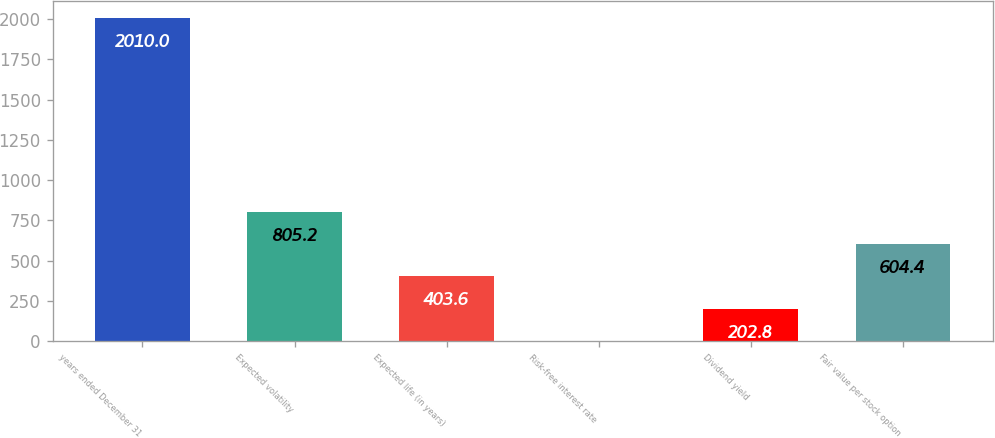<chart> <loc_0><loc_0><loc_500><loc_500><bar_chart><fcel>years ended December 31<fcel>Expected volatility<fcel>Expected life (in years)<fcel>Risk-free interest rate<fcel>Dividend yield<fcel>Fair value per stock option<nl><fcel>2010<fcel>805.2<fcel>403.6<fcel>2<fcel>202.8<fcel>604.4<nl></chart> 